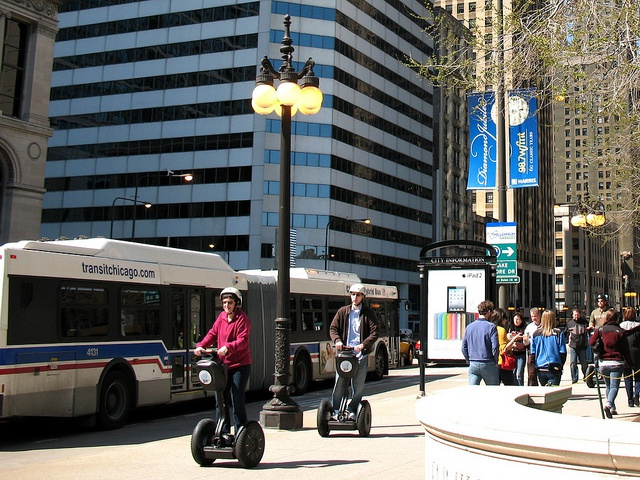Describe the objects in this image and their specific colors. I can see bus in gray, black, darkgray, and maroon tones, people in gray, black, maroon, violet, and brown tones, people in gray, black, white, and darkgray tones, people in gray, darkgray, black, and white tones, and people in gray, black, maroon, and white tones in this image. 